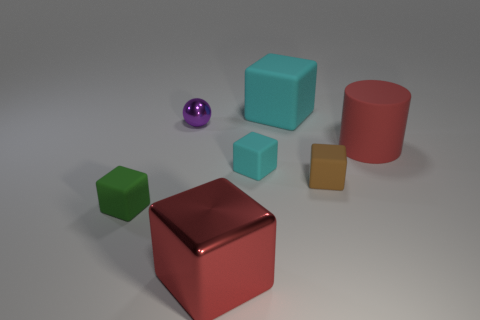Subtract all gray cylinders. How many cyan blocks are left? 2 Subtract all tiny brown cubes. How many cubes are left? 4 Subtract all brown cubes. How many cubes are left? 4 Add 3 big matte objects. How many objects exist? 10 Subtract all yellow cubes. Subtract all brown cylinders. How many cubes are left? 5 Subtract all cylinders. How many objects are left? 6 Add 5 small purple balls. How many small purple balls are left? 6 Add 7 tiny gray metal cylinders. How many tiny gray metal cylinders exist? 7 Subtract 0 yellow cylinders. How many objects are left? 7 Subtract all small green matte balls. Subtract all brown rubber cubes. How many objects are left? 6 